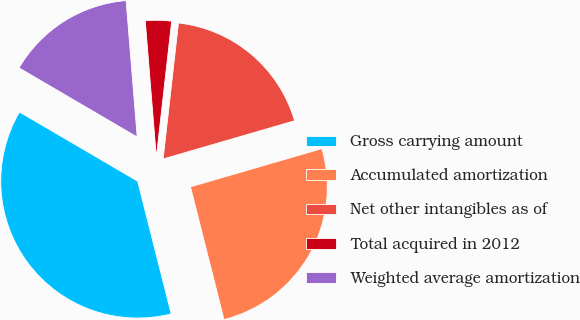Convert chart to OTSL. <chart><loc_0><loc_0><loc_500><loc_500><pie_chart><fcel>Gross carrying amount<fcel>Accumulated amortization<fcel>Net other intangibles as of<fcel>Total acquired in 2012<fcel>Weighted average amortization<nl><fcel>37.37%<fcel>25.56%<fcel>18.71%<fcel>3.08%<fcel>15.28%<nl></chart> 